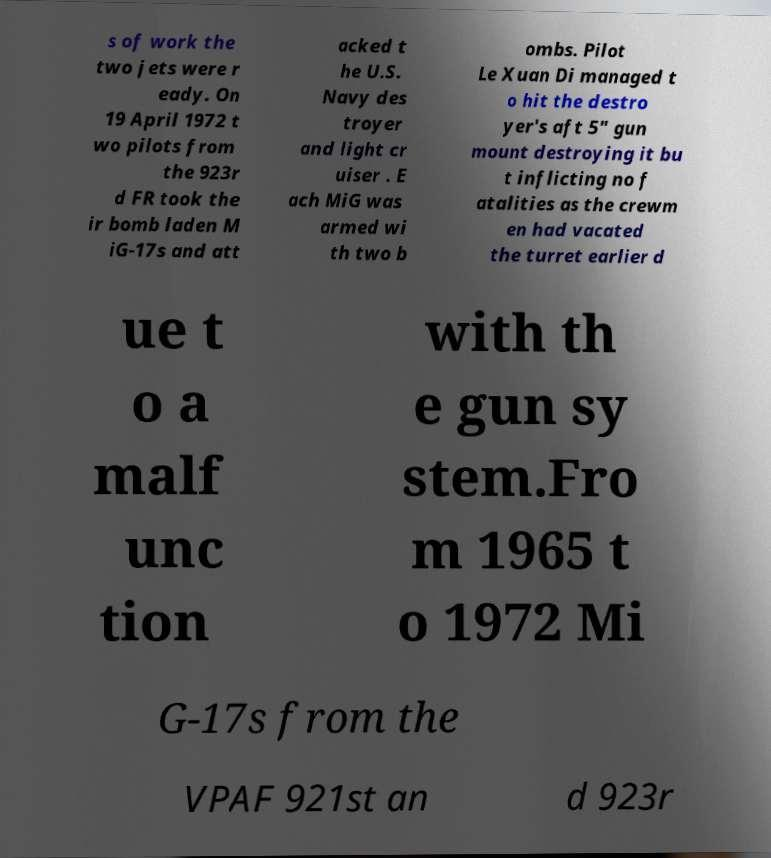Please identify and transcribe the text found in this image. s of work the two jets were r eady. On 19 April 1972 t wo pilots from the 923r d FR took the ir bomb laden M iG-17s and att acked t he U.S. Navy des troyer and light cr uiser . E ach MiG was armed wi th two b ombs. Pilot Le Xuan Di managed t o hit the destro yer's aft 5" gun mount destroying it bu t inflicting no f atalities as the crewm en had vacated the turret earlier d ue t o a malf unc tion with th e gun sy stem.Fro m 1965 t o 1972 Mi G-17s from the VPAF 921st an d 923r 